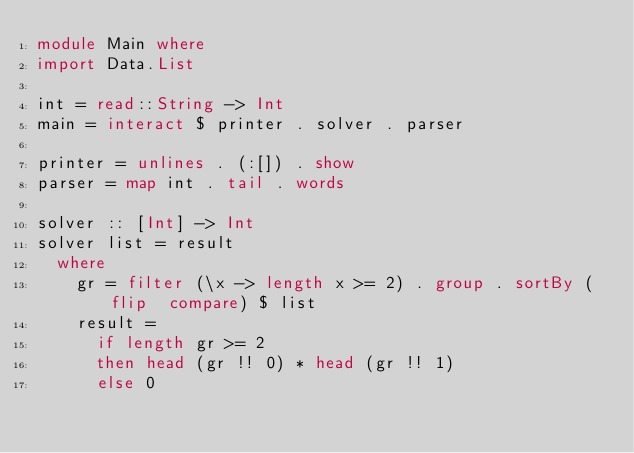Convert code to text. <code><loc_0><loc_0><loc_500><loc_500><_Haskell_>module Main where
import Data.List

int = read::String -> Int
main = interact $ printer . solver . parser

printer = unlines . (:[]) . show
parser = map int . tail . words

solver :: [Int] -> Int
solver list = result
  where
    gr = filter (\x -> length x >= 2) . group . sortBy (flip  compare) $ list
    result = 
      if length gr >= 2 
      then head (gr !! 0) * head (gr !! 1)
      else 0

</code> 